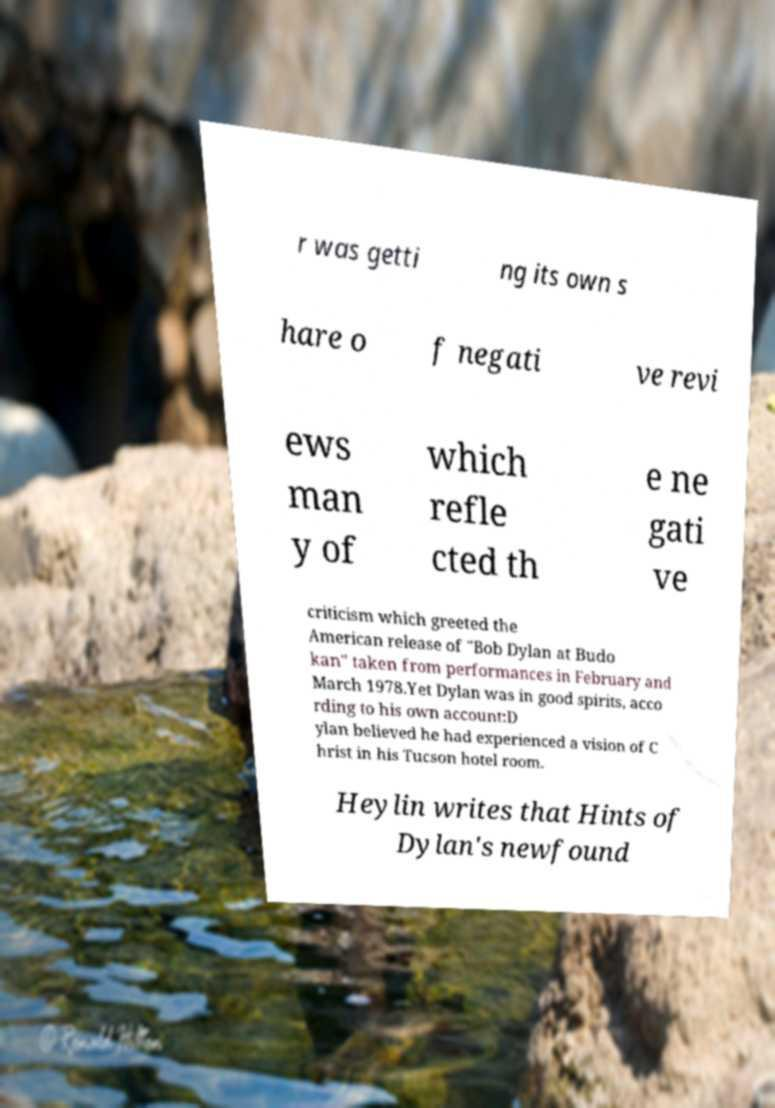I need the written content from this picture converted into text. Can you do that? r was getti ng its own s hare o f negati ve revi ews man y of which refle cted th e ne gati ve criticism which greeted the American release of "Bob Dylan at Budo kan" taken from performances in February and March 1978.Yet Dylan was in good spirits, acco rding to his own account:D ylan believed he had experienced a vision of C hrist in his Tucson hotel room. Heylin writes that Hints of Dylan's newfound 